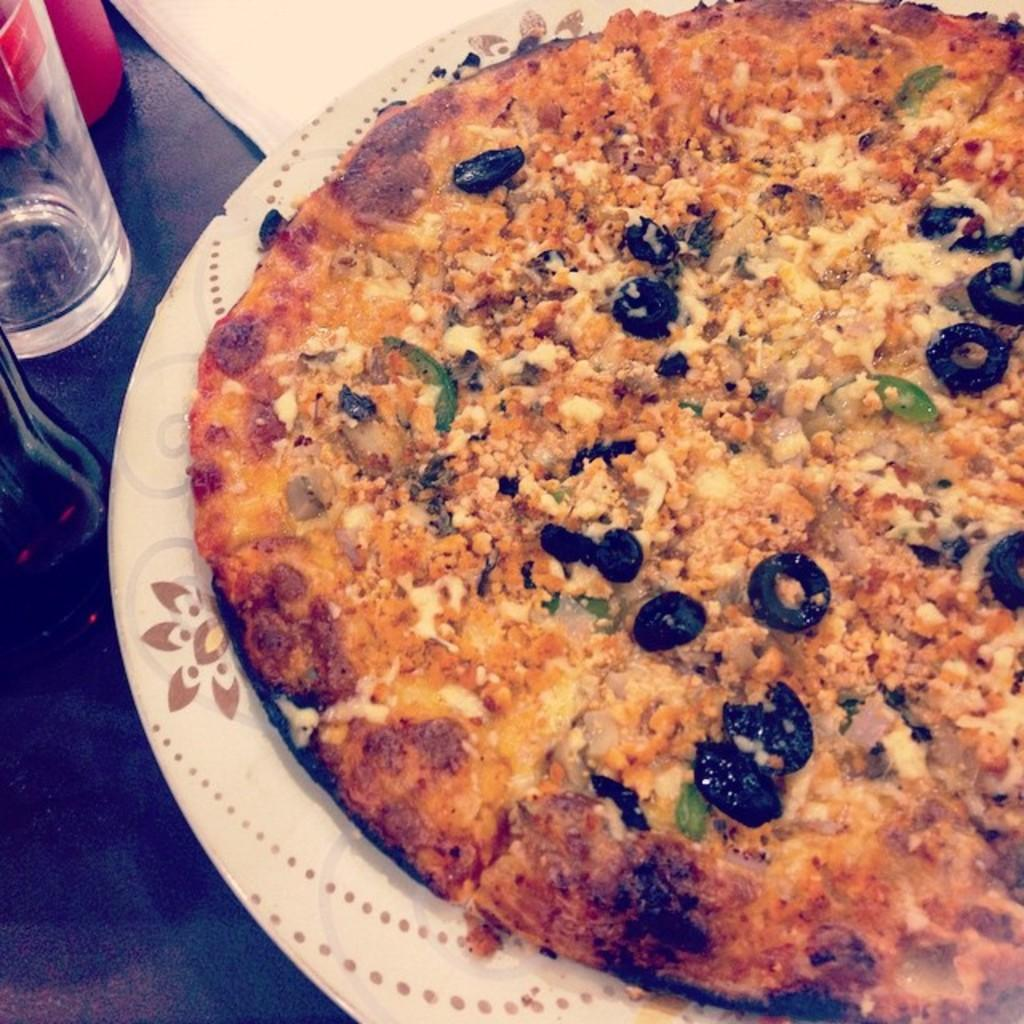What type of food is on the plate in the image? There is a pizza on a plate in the image. What beverage container is on the table? There is a water bottle on the table. What other type of container is on the table? There is a cup on the table. What item is present for wiping or blowing one's nose? There is a tissue on the table. What country is depicted on the pizza in the image? The image does not show any country depicted on the pizza; it is simply a pizza on a plate. 